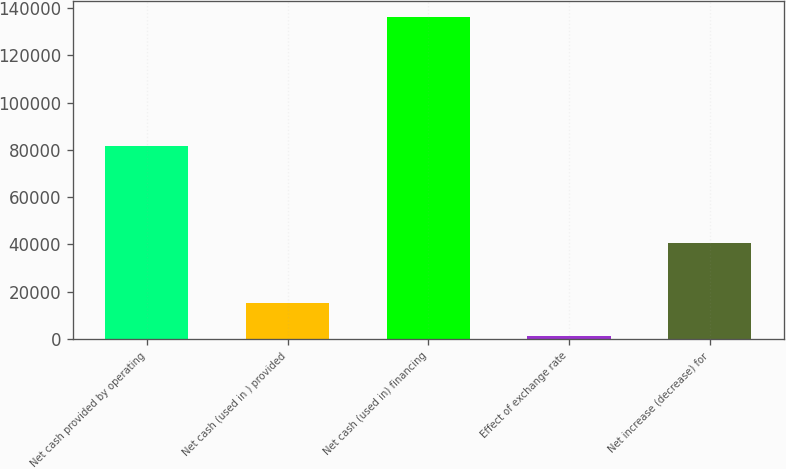Convert chart. <chart><loc_0><loc_0><loc_500><loc_500><bar_chart><fcel>Net cash provided by operating<fcel>Net cash (used in ) provided<fcel>Net cash (used in) financing<fcel>Effect of exchange rate<fcel>Net increase (decrease) for<nl><fcel>81582<fcel>15030<fcel>136175<fcel>1149<fcel>40712<nl></chart> 